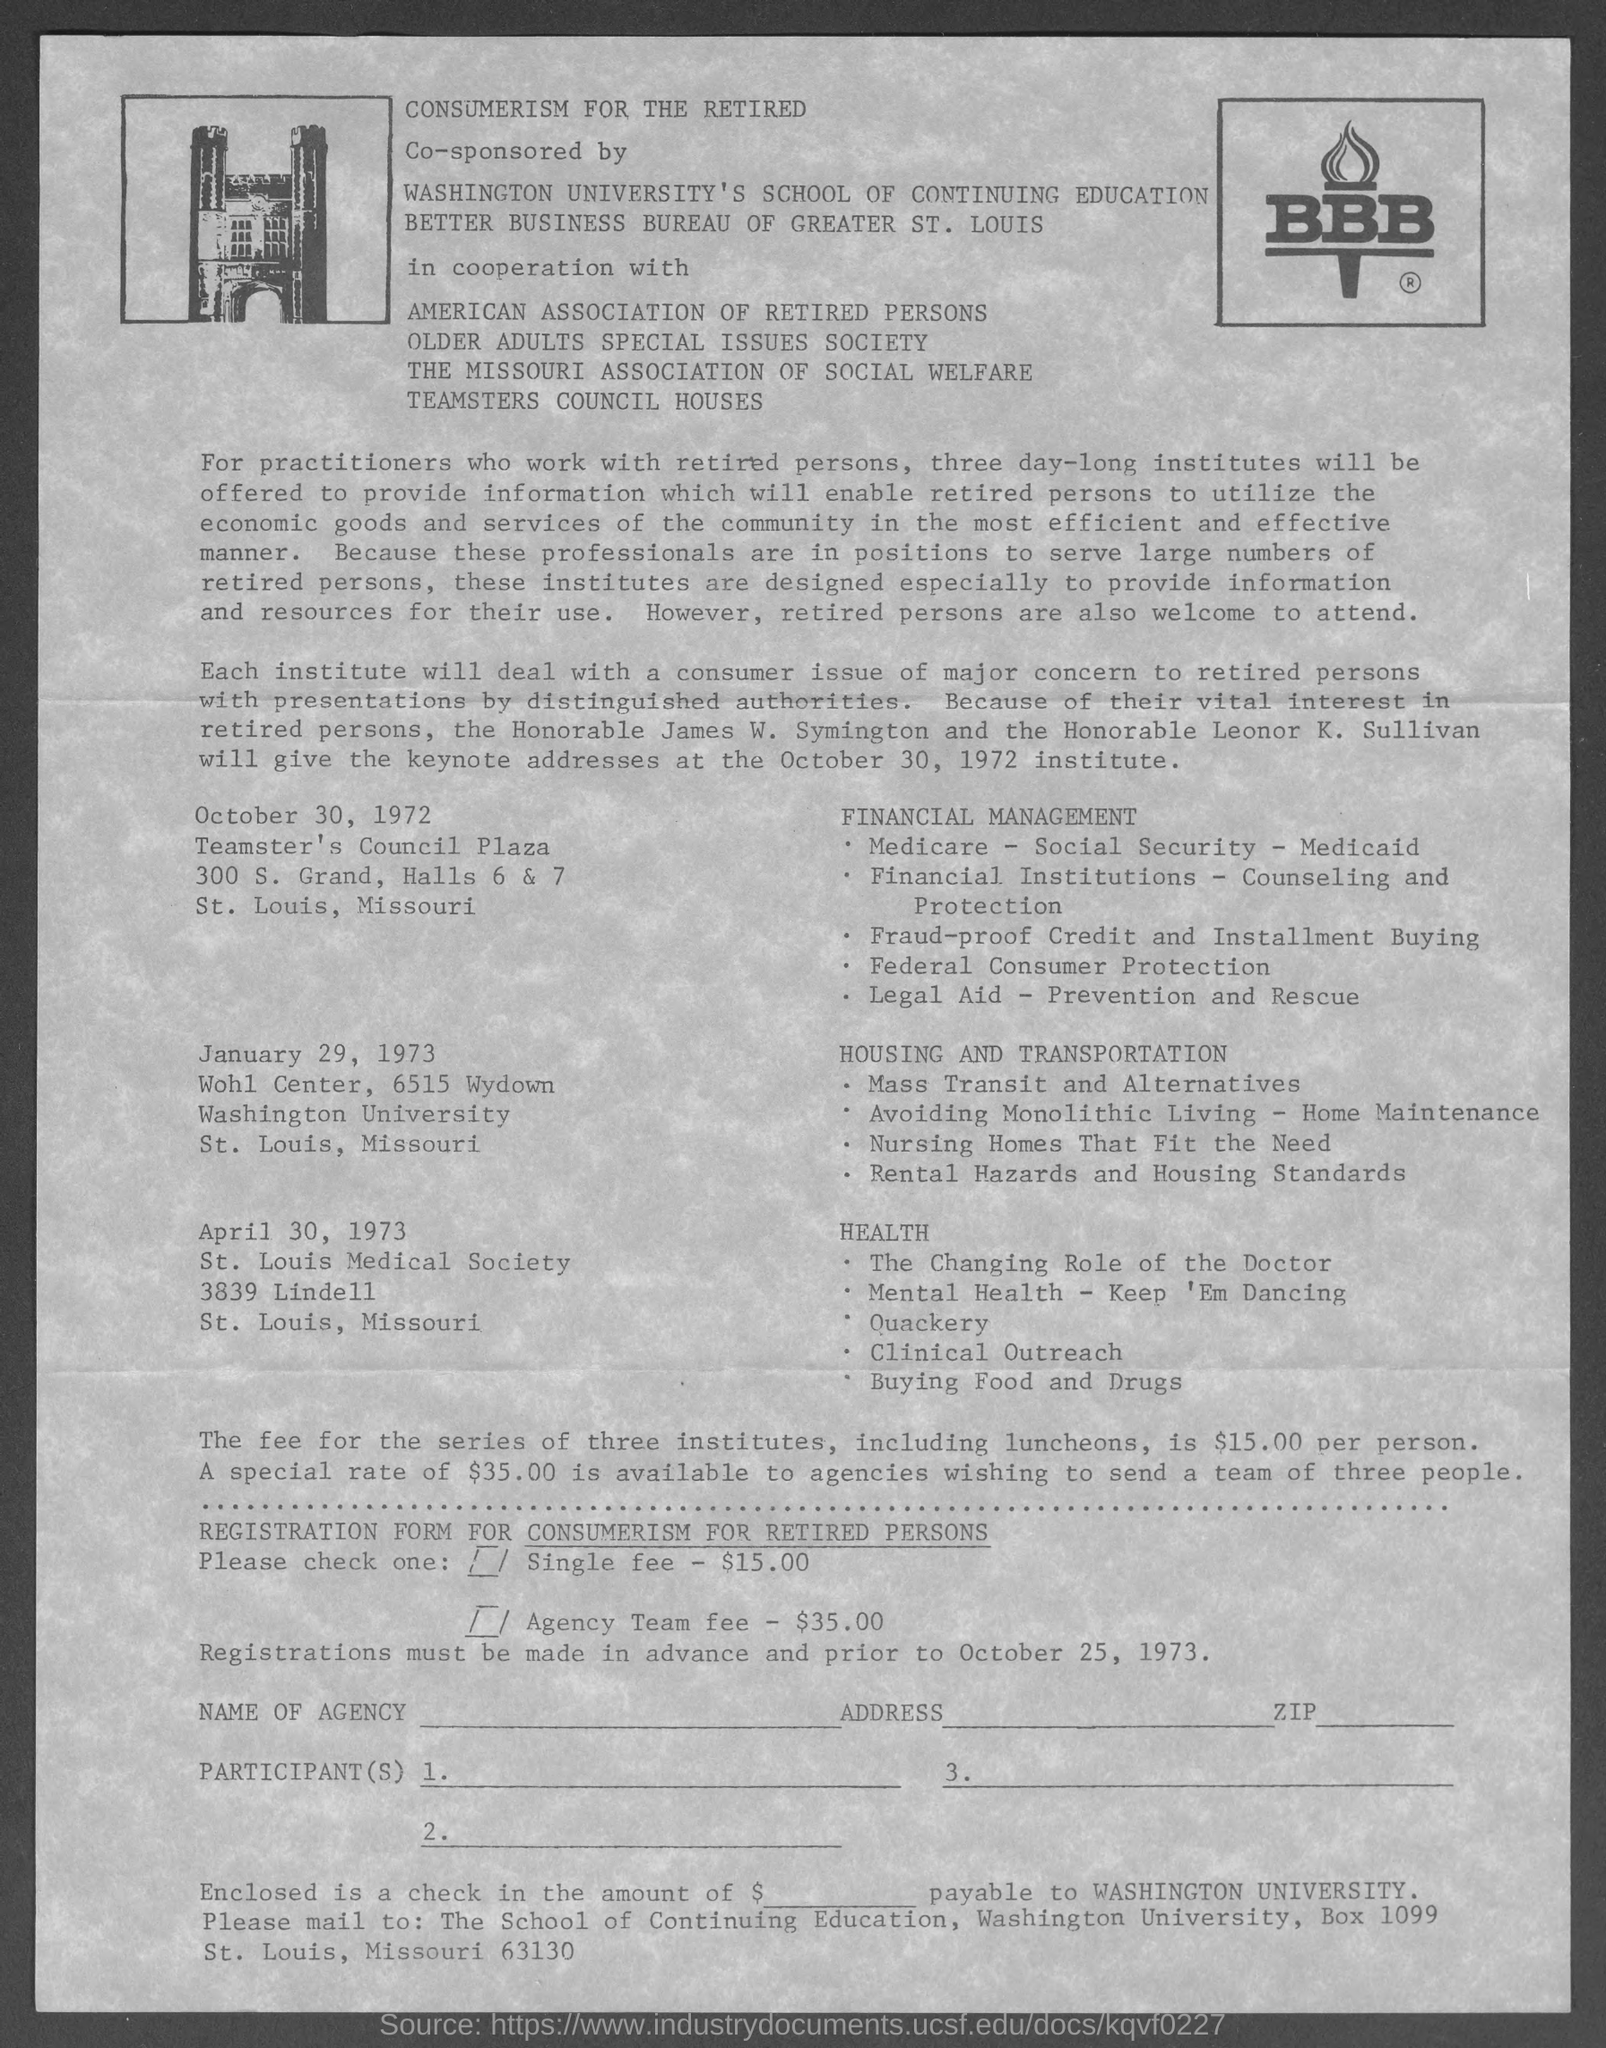List a handful of essential elements in this visual. The single fee is $15.00. The Agency Team Fee is $35.00. 